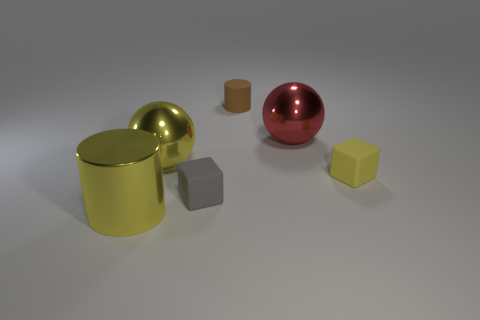There is a matte thing on the right side of the red metal thing; is its size the same as the small gray object?
Provide a short and direct response. Yes. What number of small matte cylinders are in front of the big sphere that is right of the large sphere in front of the big red sphere?
Give a very brief answer. 0. How many gray things are small cubes or large spheres?
Offer a terse response. 1. The other ball that is made of the same material as the big red ball is what color?
Your response must be concise. Yellow. How many tiny things are either brown matte things or yellow rubber cubes?
Your response must be concise. 2. Is the number of small purple cubes less than the number of large red spheres?
Your response must be concise. Yes. There is another thing that is the same shape as the brown rubber object; what color is it?
Ensure brevity in your answer.  Yellow. Is the number of small yellow blocks greater than the number of small blue balls?
Ensure brevity in your answer.  Yes. What number of other objects are the same material as the brown thing?
Your answer should be very brief. 2. There is a large object that is to the right of the brown cylinder that is to the right of the large yellow object behind the large metal cylinder; what is its shape?
Your answer should be very brief. Sphere. 